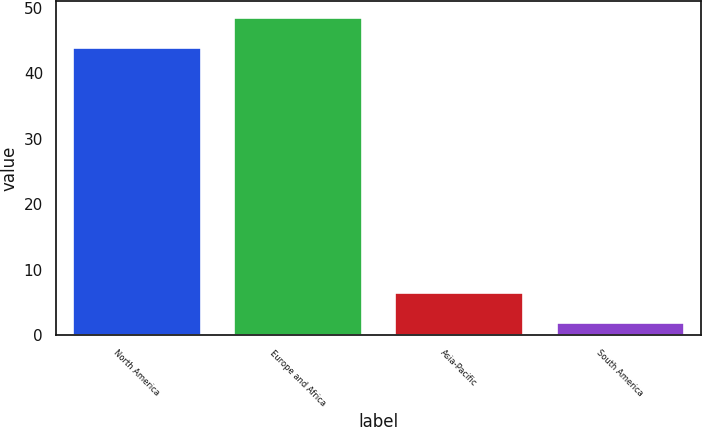Convert chart to OTSL. <chart><loc_0><loc_0><loc_500><loc_500><bar_chart><fcel>North America<fcel>Europe and Africa<fcel>Asia-Pacific<fcel>South America<nl><fcel>44<fcel>48.6<fcel>6.6<fcel>2<nl></chart> 